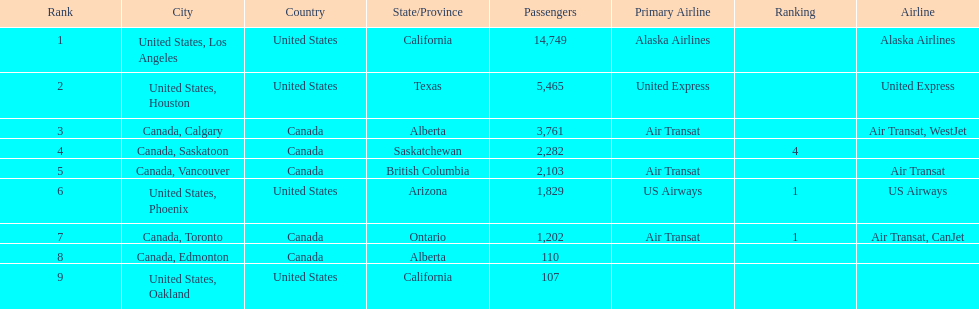Where are the destinations of the airport? United States, Los Angeles, United States, Houston, Canada, Calgary, Canada, Saskatoon, Canada, Vancouver, United States, Phoenix, Canada, Toronto, Canada, Edmonton, United States, Oakland. What is the number of passengers to phoenix? 1,829. 